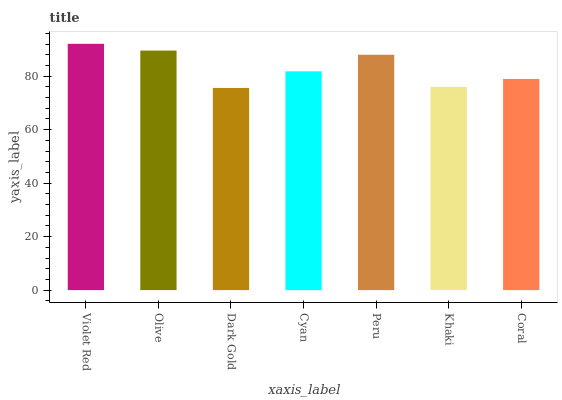Is Dark Gold the minimum?
Answer yes or no. Yes. Is Violet Red the maximum?
Answer yes or no. Yes. Is Olive the minimum?
Answer yes or no. No. Is Olive the maximum?
Answer yes or no. No. Is Violet Red greater than Olive?
Answer yes or no. Yes. Is Olive less than Violet Red?
Answer yes or no. Yes. Is Olive greater than Violet Red?
Answer yes or no. No. Is Violet Red less than Olive?
Answer yes or no. No. Is Cyan the high median?
Answer yes or no. Yes. Is Cyan the low median?
Answer yes or no. Yes. Is Khaki the high median?
Answer yes or no. No. Is Khaki the low median?
Answer yes or no. No. 